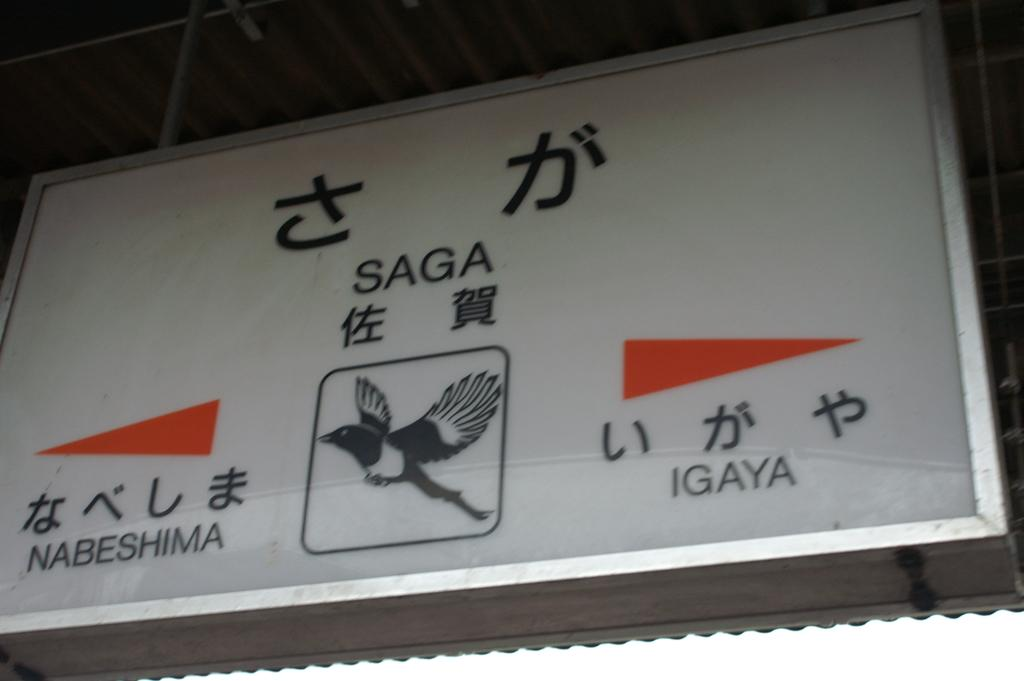What is the main object in the center of the image? There is a board in the center of the image. What is written or depicted on the board? There is text on the board and a drawing of a bird. What can be seen above the board in the image? There is a ceiling visible in the image. What type of structure is present in the image? There are poles in the image. How many tomatoes are hanging from the poles in the image? There are no tomatoes present in the image; only a board with text and a drawing of a bird, a ceiling, and poles can be seen. 